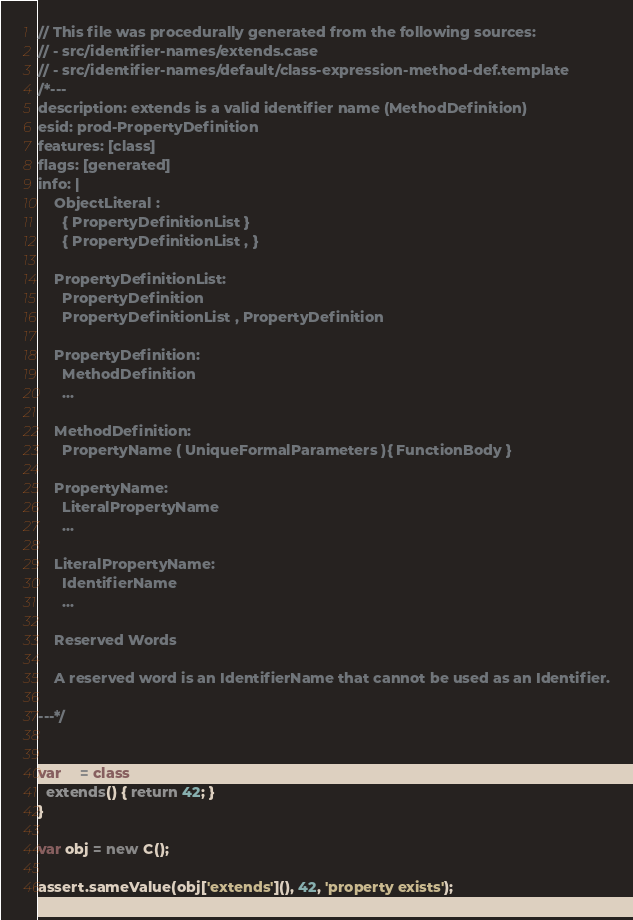<code> <loc_0><loc_0><loc_500><loc_500><_JavaScript_>// This file was procedurally generated from the following sources:
// - src/identifier-names/extends.case
// - src/identifier-names/default/class-expression-method-def.template
/*---
description: extends is a valid identifier name (MethodDefinition)
esid: prod-PropertyDefinition
features: [class]
flags: [generated]
info: |
    ObjectLiteral :
      { PropertyDefinitionList }
      { PropertyDefinitionList , }

    PropertyDefinitionList:
      PropertyDefinition
      PropertyDefinitionList , PropertyDefinition

    PropertyDefinition:
      MethodDefinition
      ...

    MethodDefinition:
      PropertyName ( UniqueFormalParameters ){ FunctionBody }

    PropertyName:
      LiteralPropertyName
      ...

    LiteralPropertyName:
      IdentifierName
      ...

    Reserved Words

    A reserved word is an IdentifierName that cannot be used as an Identifier.

---*/


var C = class {
  extends() { return 42; }
}

var obj = new C();

assert.sameValue(obj['extends'](), 42, 'property exists');
</code> 